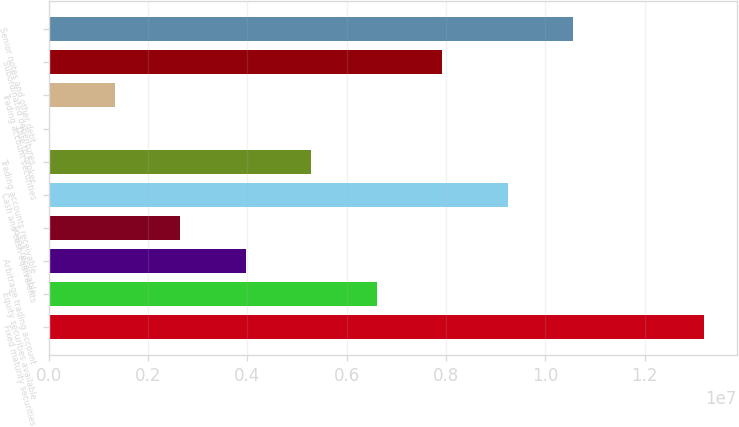Convert chart. <chart><loc_0><loc_0><loc_500><loc_500><bar_chart><fcel>Fixed maturity securities<fcel>Equity securities available<fcel>Arbitrage trading account<fcel>Loans receivable<fcel>Cash and cash equivalents<fcel>Trading accounts receivable<fcel>Due to broker<fcel>Trading account securities<fcel>Subordinated debentures<fcel>Senior notes and other debt<nl><fcel>1.31907e+07<fcel>6.60504e+06<fcel>3.97079e+06<fcel>2.65367e+06<fcel>9.23929e+06<fcel>5.28792e+06<fcel>19416<fcel>1.33654e+06<fcel>7.92217e+06<fcel>1.05564e+07<nl></chart> 